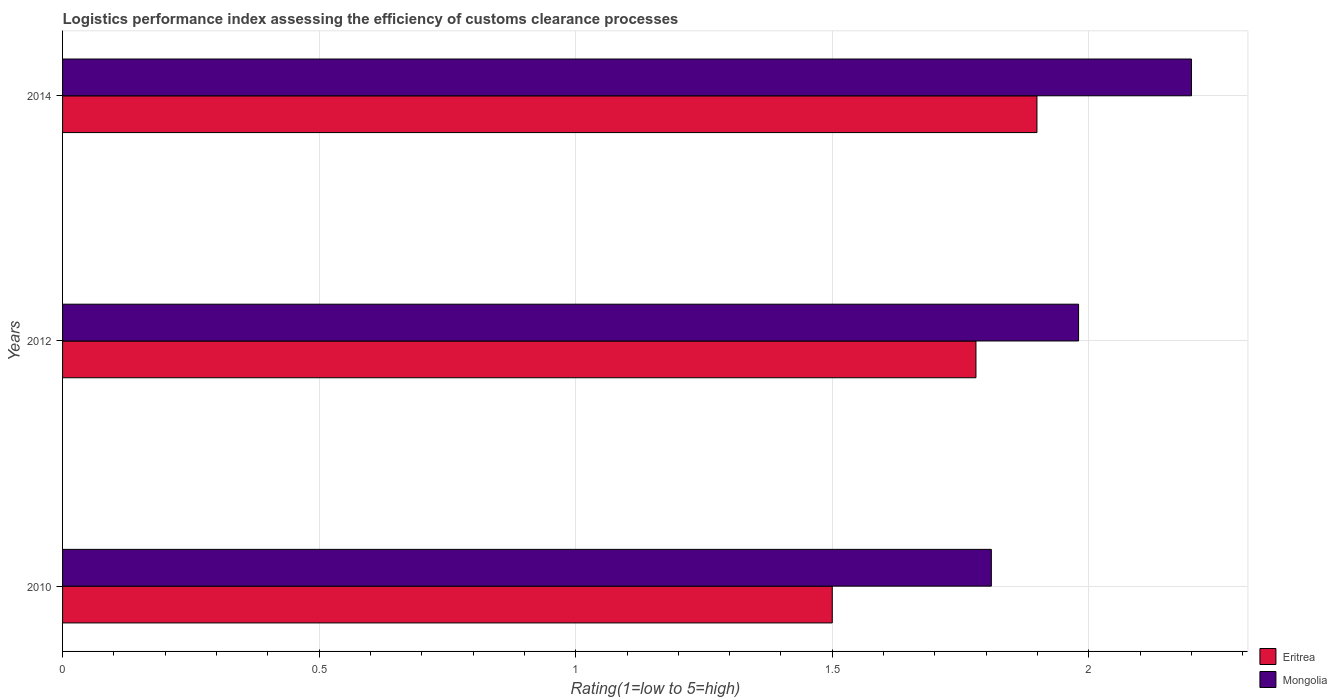How many different coloured bars are there?
Give a very brief answer. 2. How many groups of bars are there?
Offer a terse response. 3. Are the number of bars per tick equal to the number of legend labels?
Offer a terse response. Yes. Are the number of bars on each tick of the Y-axis equal?
Ensure brevity in your answer.  Yes. What is the label of the 1st group of bars from the top?
Keep it short and to the point. 2014. What is the Logistic performance index in Eritrea in 2014?
Your answer should be compact. 1.9. Across all years, what is the maximum Logistic performance index in Mongolia?
Your answer should be compact. 2.2. Across all years, what is the minimum Logistic performance index in Mongolia?
Offer a very short reply. 1.81. In which year was the Logistic performance index in Mongolia maximum?
Offer a terse response. 2014. In which year was the Logistic performance index in Eritrea minimum?
Provide a short and direct response. 2010. What is the total Logistic performance index in Mongolia in the graph?
Ensure brevity in your answer.  5.99. What is the difference between the Logistic performance index in Mongolia in 2012 and that in 2014?
Your response must be concise. -0.22. What is the difference between the Logistic performance index in Mongolia in 2010 and the Logistic performance index in Eritrea in 2012?
Offer a terse response. 0.03. What is the average Logistic performance index in Mongolia per year?
Provide a succinct answer. 2. In the year 2012, what is the difference between the Logistic performance index in Mongolia and Logistic performance index in Eritrea?
Offer a terse response. 0.2. In how many years, is the Logistic performance index in Eritrea greater than 1 ?
Make the answer very short. 3. What is the ratio of the Logistic performance index in Mongolia in 2010 to that in 2014?
Provide a succinct answer. 0.82. What is the difference between the highest and the second highest Logistic performance index in Mongolia?
Your answer should be compact. 0.22. What is the difference between the highest and the lowest Logistic performance index in Eritrea?
Offer a very short reply. 0.4. In how many years, is the Logistic performance index in Mongolia greater than the average Logistic performance index in Mongolia taken over all years?
Your response must be concise. 1. What does the 2nd bar from the top in 2012 represents?
Your answer should be very brief. Eritrea. What does the 1st bar from the bottom in 2010 represents?
Your answer should be compact. Eritrea. How many bars are there?
Offer a terse response. 6. How many years are there in the graph?
Your response must be concise. 3. Are the values on the major ticks of X-axis written in scientific E-notation?
Keep it short and to the point. No. Does the graph contain grids?
Keep it short and to the point. Yes. Where does the legend appear in the graph?
Keep it short and to the point. Bottom right. How many legend labels are there?
Offer a very short reply. 2. What is the title of the graph?
Give a very brief answer. Logistics performance index assessing the efficiency of customs clearance processes. What is the label or title of the X-axis?
Your answer should be compact. Rating(1=low to 5=high). What is the label or title of the Y-axis?
Keep it short and to the point. Years. What is the Rating(1=low to 5=high) of Eritrea in 2010?
Your answer should be compact. 1.5. What is the Rating(1=low to 5=high) in Mongolia in 2010?
Your response must be concise. 1.81. What is the Rating(1=low to 5=high) in Eritrea in 2012?
Offer a terse response. 1.78. What is the Rating(1=low to 5=high) in Mongolia in 2012?
Your response must be concise. 1.98. What is the Rating(1=low to 5=high) of Eritrea in 2014?
Provide a short and direct response. 1.9. Across all years, what is the maximum Rating(1=low to 5=high) of Eritrea?
Keep it short and to the point. 1.9. Across all years, what is the maximum Rating(1=low to 5=high) of Mongolia?
Keep it short and to the point. 2.2. Across all years, what is the minimum Rating(1=low to 5=high) in Eritrea?
Your response must be concise. 1.5. Across all years, what is the minimum Rating(1=low to 5=high) of Mongolia?
Your answer should be compact. 1.81. What is the total Rating(1=low to 5=high) in Eritrea in the graph?
Your answer should be very brief. 5.18. What is the total Rating(1=low to 5=high) in Mongolia in the graph?
Offer a very short reply. 5.99. What is the difference between the Rating(1=low to 5=high) in Eritrea in 2010 and that in 2012?
Offer a terse response. -0.28. What is the difference between the Rating(1=low to 5=high) in Mongolia in 2010 and that in 2012?
Provide a short and direct response. -0.17. What is the difference between the Rating(1=low to 5=high) in Eritrea in 2010 and that in 2014?
Your response must be concise. -0.4. What is the difference between the Rating(1=low to 5=high) of Mongolia in 2010 and that in 2014?
Give a very brief answer. -0.39. What is the difference between the Rating(1=low to 5=high) in Eritrea in 2012 and that in 2014?
Keep it short and to the point. -0.12. What is the difference between the Rating(1=low to 5=high) in Mongolia in 2012 and that in 2014?
Offer a very short reply. -0.22. What is the difference between the Rating(1=low to 5=high) of Eritrea in 2010 and the Rating(1=low to 5=high) of Mongolia in 2012?
Give a very brief answer. -0.48. What is the difference between the Rating(1=low to 5=high) of Eritrea in 2012 and the Rating(1=low to 5=high) of Mongolia in 2014?
Make the answer very short. -0.42. What is the average Rating(1=low to 5=high) in Eritrea per year?
Your answer should be compact. 1.73. What is the average Rating(1=low to 5=high) of Mongolia per year?
Provide a succinct answer. 2. In the year 2010, what is the difference between the Rating(1=low to 5=high) of Eritrea and Rating(1=low to 5=high) of Mongolia?
Make the answer very short. -0.31. In the year 2014, what is the difference between the Rating(1=low to 5=high) of Eritrea and Rating(1=low to 5=high) of Mongolia?
Your answer should be compact. -0.3. What is the ratio of the Rating(1=low to 5=high) in Eritrea in 2010 to that in 2012?
Provide a short and direct response. 0.84. What is the ratio of the Rating(1=low to 5=high) of Mongolia in 2010 to that in 2012?
Your answer should be very brief. 0.91. What is the ratio of the Rating(1=low to 5=high) of Eritrea in 2010 to that in 2014?
Offer a terse response. 0.79. What is the ratio of the Rating(1=low to 5=high) of Mongolia in 2010 to that in 2014?
Your response must be concise. 0.82. What is the ratio of the Rating(1=low to 5=high) in Eritrea in 2012 to that in 2014?
Offer a very short reply. 0.94. What is the ratio of the Rating(1=low to 5=high) in Mongolia in 2012 to that in 2014?
Offer a very short reply. 0.9. What is the difference between the highest and the second highest Rating(1=low to 5=high) in Eritrea?
Provide a short and direct response. 0.12. What is the difference between the highest and the second highest Rating(1=low to 5=high) of Mongolia?
Provide a short and direct response. 0.22. What is the difference between the highest and the lowest Rating(1=low to 5=high) in Eritrea?
Give a very brief answer. 0.4. What is the difference between the highest and the lowest Rating(1=low to 5=high) in Mongolia?
Give a very brief answer. 0.39. 